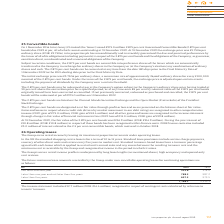According to Intu Properties's financial document, What is the amount of contingent rents calculated by reference to tenants' turnover in 2019? According to the financial document, £12.7 million. The relevant text states: "The income statement includes £12.7 million (2018: £14.4 million) recognised in respect of contingent rents calculated by reference to tenants’..." Also, How long is the lease for a standard shopping centre in the UK? According to the financial document, 10 to 15 years. The relevant text states: "e standard shopping centre lease is for a term of 10 to 15 years. Standard lease provisions include service charge payments, recovery of other direct costs and revi..." Also, What is the amount of contingent rents calculated by reference to tenants' turnover in 2018? According to the financial document, £14.4 million. The relevant text states: "The income statement includes £12.7 million (2018: £14.4 million) recognised in respect of contingent rents calculated by reference to tenants’ turnover...." Also, can you calculate: What is the percentage change in the amount of contingent rents calculated by reference to tenants' turnover from 2018 to 2019? To answer this question, I need to perform calculations using the financial data. The calculation is: (12.7-14.4)/14.4, which equals -11.81 (percentage). This is based on the information: "The income statement includes £12.7 million (2018: £14.4 million) recognised in respect of contingent rents calculated by reference to e income statement includes £12.7 million (2018: £14.4 million) r..." The key data points involved are: 12.7, 14.4. Additionally, In which year is there  higher future minimum lease amounts receivable? According to the financial document, 2018. The relevant text states: "£m 2019 2018..." Also, can you calculate: What is the percentage change in the future minimum lease amount receivable later than five years from to 2018 to 2019? To answer this question, I need to perform calculations using the financial data. The calculation is: (657.3-973.5)/973.5, which equals -32.48 (percentage). This is based on the information: "Later than five years 657.3 973.5 Later than five years 657.3 973.5..." The key data points involved are: 657.3, 973.5. 